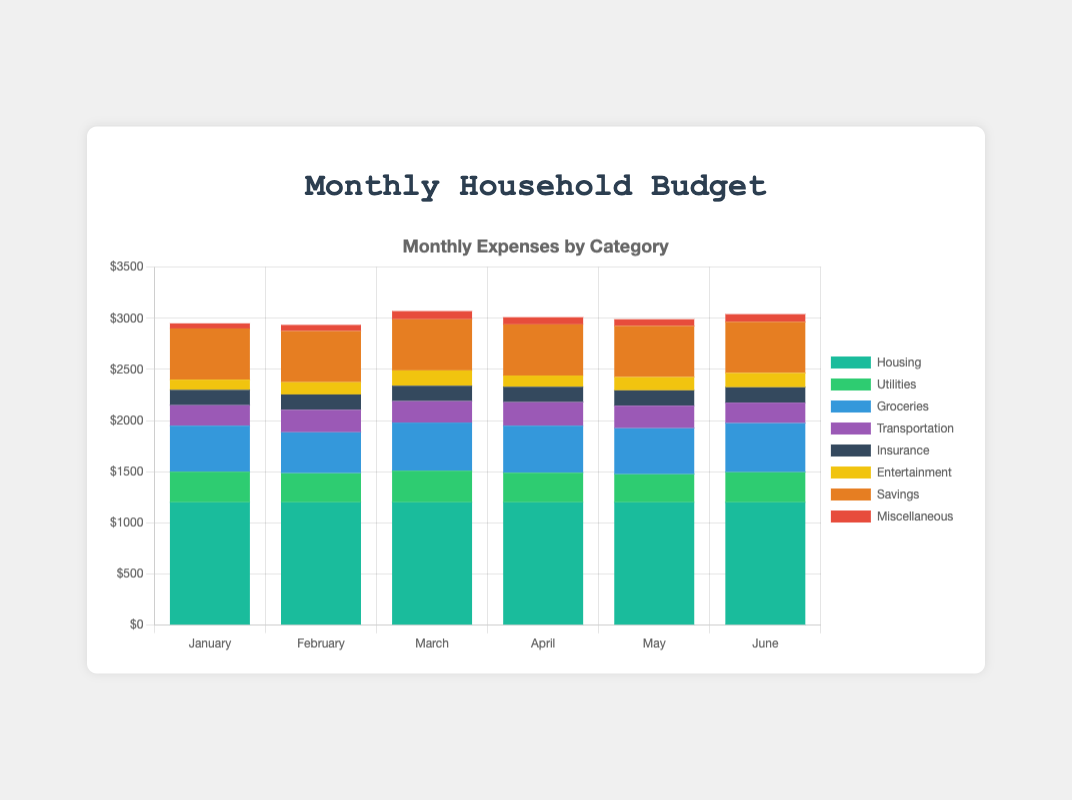What's the total expenditure for Housing over the six months? To find the total expenditure for Housing, sum up the corresponding values for each month: 1200 + 1200 + 1200 + 1200 + 1200 + 1200 = 7200
Answer: 7200 Which category had the highest expenditure in June? Refer to the bars for June. Housing has the tallest bar segment, indicating the highest expenditure for that month.
Answer: Housing What is the difference in Groceries expenditure between March and May? Look at the heights of the Groceries segments for March and May: 470 (March) - 450 (May) = 20
Answer: 20 Which month had the lowest total expenditure? Sum the heights of all segments in each month and compare. February has the lowest total expenditure.
Answer: February How much higher was the Transportation expenditure in April compared to January? Compare the Transportation segments for April (230) and January (200). The difference is 230 - 200 = 30
Answer: 30 What is the average monthly expenditure for Utilities? Sum the Utilities expenditures over six months and divide by 6: (300 + 285 + 310 + 290 + 275 + 295) / 6 = 1755 / 6 ≈ 292.5
Answer: 292.5 How did Miscellaneous expenses change from January to June? Compare the Miscellaneous segments from January (50) to June (75). The increase is 75 - 50 = 25
Answer: 25 Which category showed the most variability in monthly expenses? By comparing the height variability of all categories across months, Entertainment shows the most fluctuation.
Answer: Entertainment What is the total Savings over the six-month period? Sum the Savings expenditures for each month: 500 + 500 + 500 + 500 + 500 + 500 = 3000
Answer: 3000 How much did the total monthly expenses increase from February to March? Sum the total expenses for February and March, then find the difference: (1200 + 285 + 400 + 220 + 150 + 120 + 500 + 60) = 2935 for February and (1200 + 310 + 470 + 210 + 150 + 150 + 500 + 80) = 3070 for March. The increase is 3070 - 2935 = 135
Answer: 135 